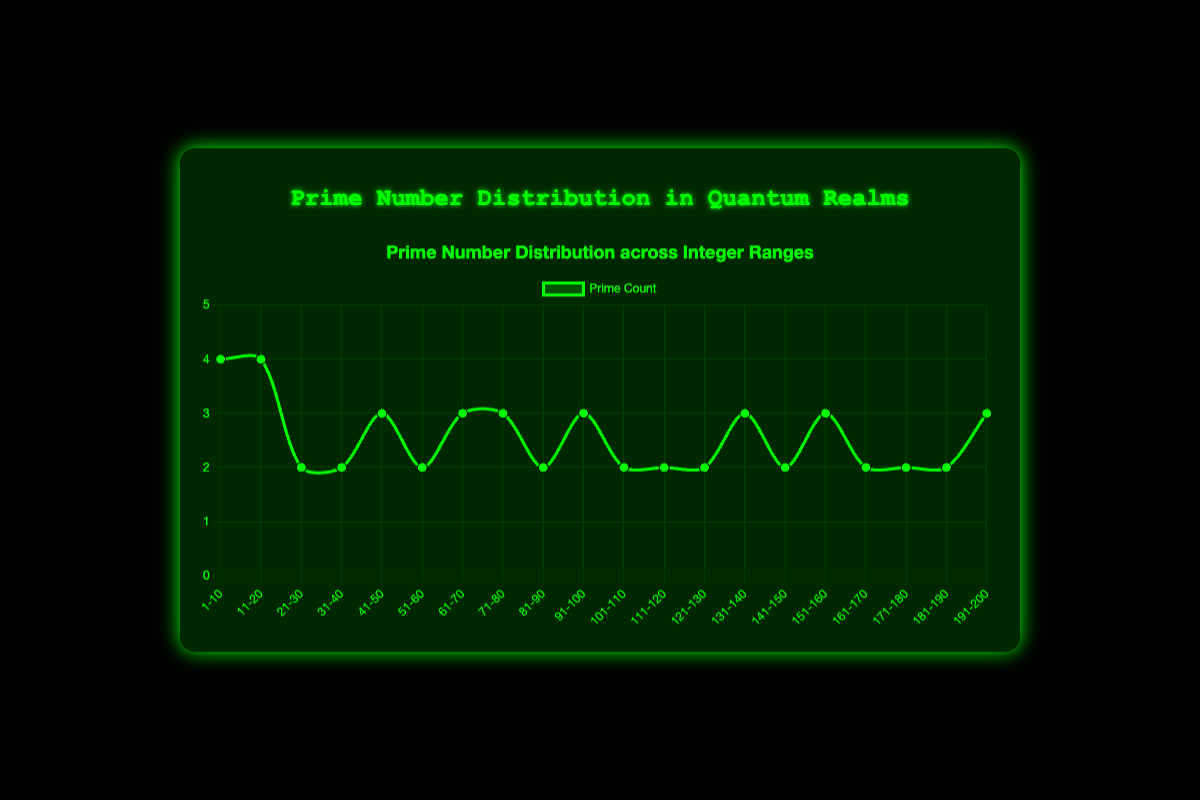What is the prime count in the integer range 91-100? The chart shows the prime counts for ranges of integers. Find the "91-100" range and observe the data point.
Answer: 3 Which integer range has the highest prime count? Look across all the data points to find the range with the maximum y-axis value. The highest value in the dataset is 4. This occurs in the "1-10" and "11-20" ranges.
Answer: 1-10 and 11-20 What is the average prime count for the integer ranges 1-20? Add the prime counts for the ranges "1-10" and "11-20" and divide by the number of ranges (2). (4 + 4) / 2 = 4.
Answer: 4 Which integer ranges have an equal prime count to the range 41-50? First, identify the prime count in "41-50" (which is 3), then find other ranges with the same prime count. These are "61-70", "71-80", "91-100", "131-140", "151-160", and "191-200".
Answer: 61-70, 71-80, 91-100, 131-140, 151-160, 191-200 What is the total sum of prime counts from the ranges 51-60 and 61-70? Add the prime counts from the "51-60" range (2) and "61-70" range (3). (2 + 3) = 5.
Answer: 5 In which integer range(s) does the prime count drop compared to the previous range? Compare the prime counts of each pair of successive ranges. Drops occur from "11-20" (4) to "21-30" (2) and "41-50" (3) to "51-60" (2).
Answer: 21-30, 51-60 Which integer range has the lowest prime count? Look across all the data points to find the range with the minimum y-axis value. The lowest value in the dataset is 2. This occurs in many ranges, including "21-30", "31-40", etc.
Answer: 21-30, 31-40, 51-60, 81-90, 101-110, 111-120, 121-130, 141-150, 161-170, 171-180, 181-190 How many prime counts are greater than 2 in the data? Count the number of data points with a prime count greater than 2. The ranges are "1-10", "11-20", "41-50", "61-70", "71-80", "91-100", "131-140", "151-160", "191-200". There are 9 such ranges.
Answer: 9 